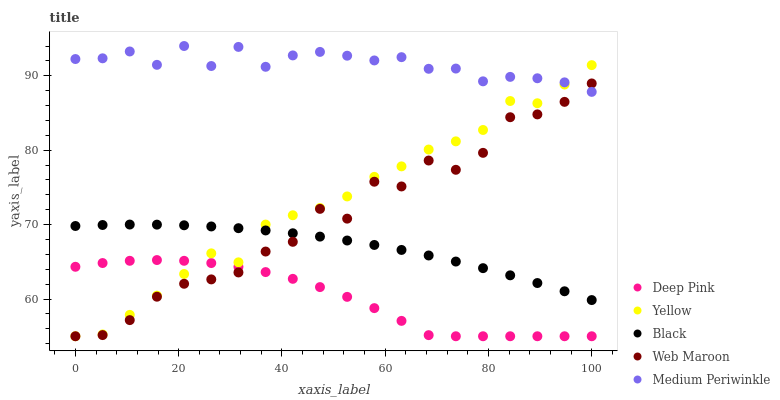Does Deep Pink have the minimum area under the curve?
Answer yes or no. Yes. Does Medium Periwinkle have the maximum area under the curve?
Answer yes or no. Yes. Does Black have the minimum area under the curve?
Answer yes or no. No. Does Black have the maximum area under the curve?
Answer yes or no. No. Is Black the smoothest?
Answer yes or no. Yes. Is Web Maroon the roughest?
Answer yes or no. Yes. Is Deep Pink the smoothest?
Answer yes or no. No. Is Deep Pink the roughest?
Answer yes or no. No. Does Web Maroon have the lowest value?
Answer yes or no. Yes. Does Black have the lowest value?
Answer yes or no. No. Does Medium Periwinkle have the highest value?
Answer yes or no. Yes. Does Black have the highest value?
Answer yes or no. No. Is Black less than Medium Periwinkle?
Answer yes or no. Yes. Is Black greater than Deep Pink?
Answer yes or no. Yes. Does Medium Periwinkle intersect Web Maroon?
Answer yes or no. Yes. Is Medium Periwinkle less than Web Maroon?
Answer yes or no. No. Is Medium Periwinkle greater than Web Maroon?
Answer yes or no. No. Does Black intersect Medium Periwinkle?
Answer yes or no. No. 